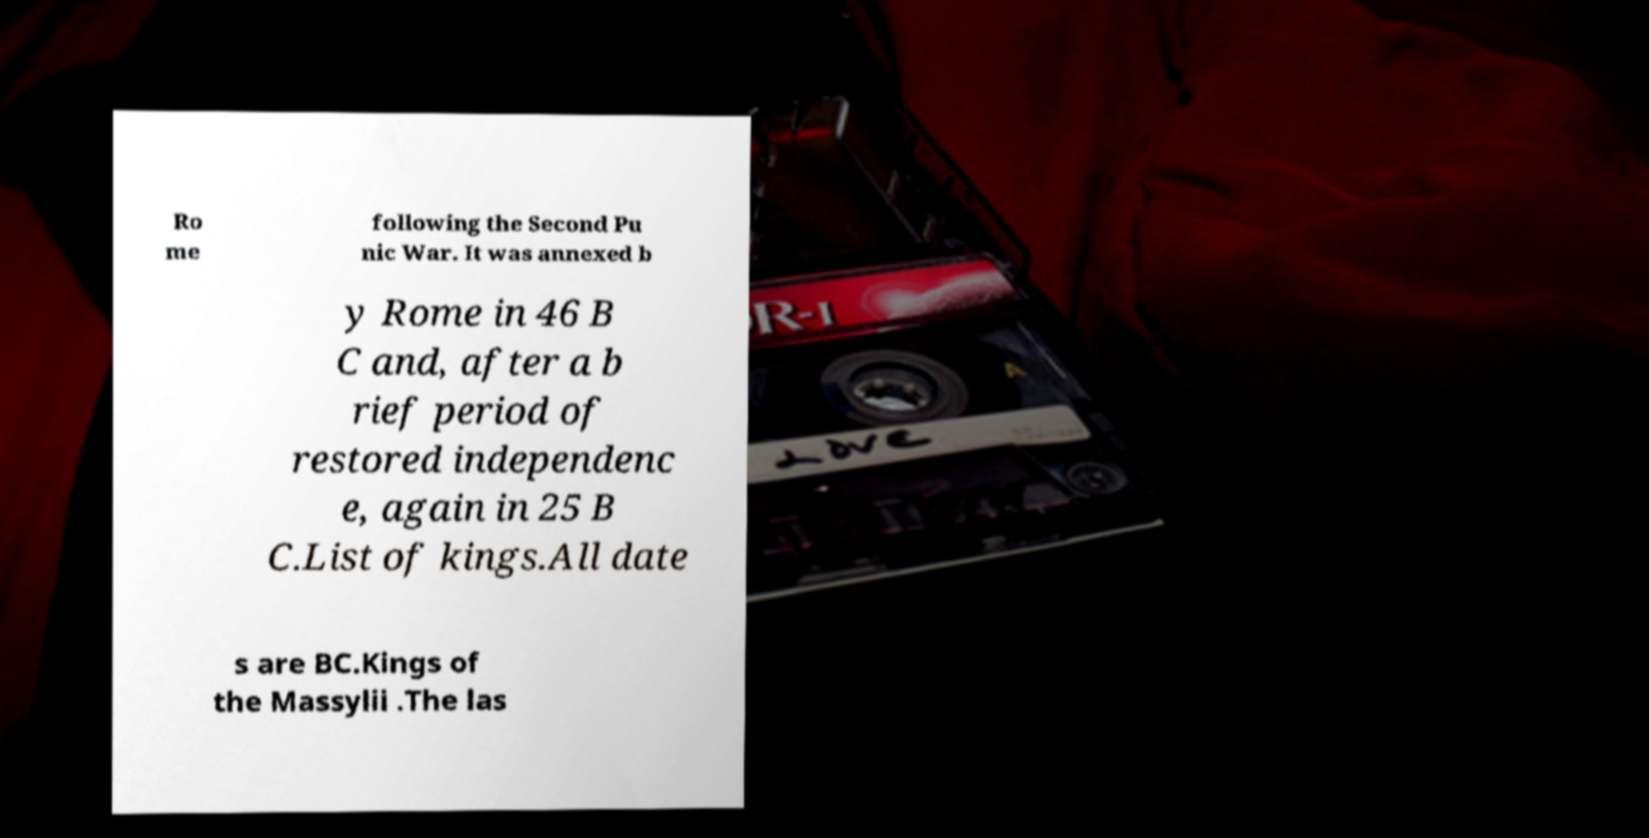Please identify and transcribe the text found in this image. Ro me following the Second Pu nic War. It was annexed b y Rome in 46 B C and, after a b rief period of restored independenc e, again in 25 B C.List of kings.All date s are BC.Kings of the Massylii .The las 